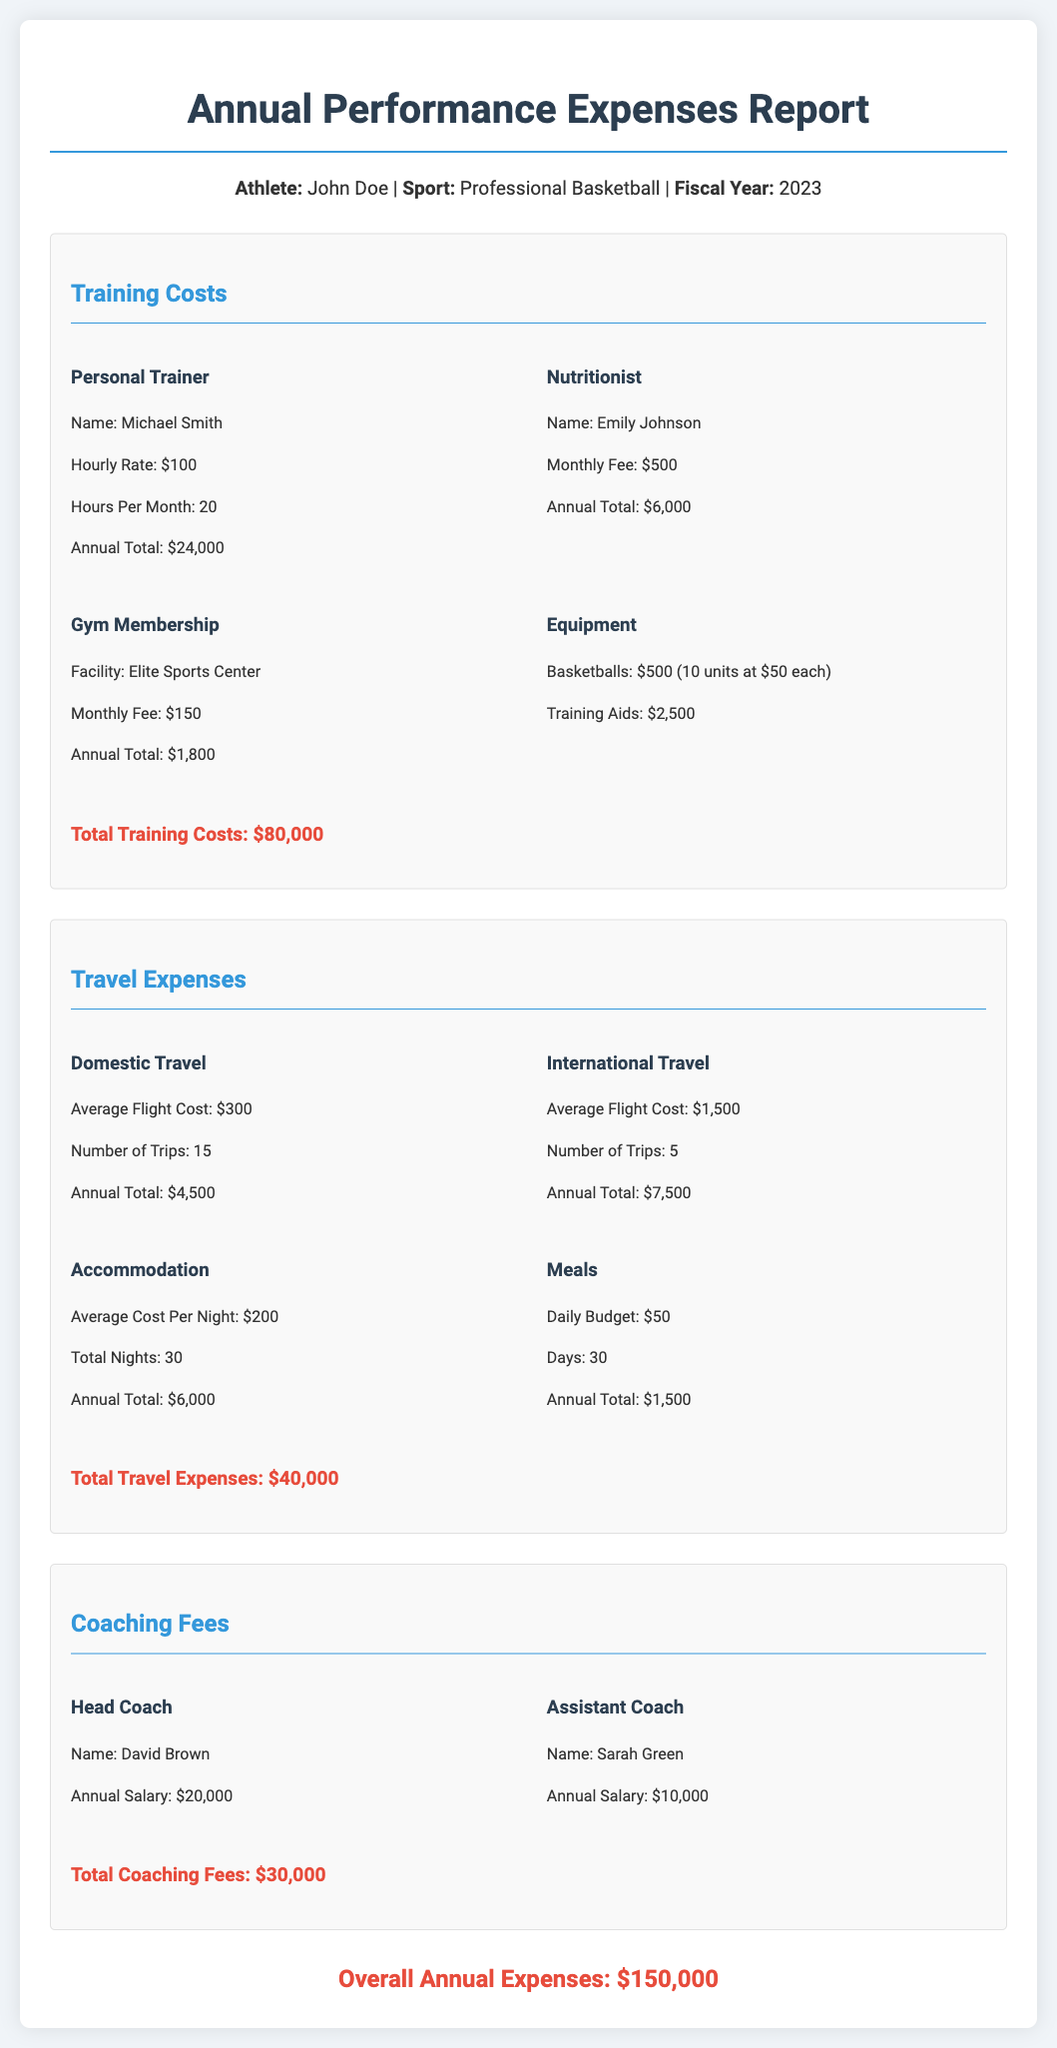What is the total training costs? The total training costs are provided at the end of the training section, totaling all expenses related to training, which is $80,000.
Answer: $80,000 Who is the personal trainer? The document lists the personal trainer's name in the training costs section, which is Michael Smith.
Answer: Michael Smith How many trips were made for domestic travel? The document specifies the number of domestic trips in the travel expenses section, which is 15.
Answer: 15 What is the annual salary of the head coach? The annual salary for the head coach is mentioned in the coaching fees section, which is $20,000.
Answer: $20,000 What is the average cost of an international flight? The average cost for international flights is provided in the travel expenses section as $1,500.
Answer: $1,500 What is the total amount spent on meals during travel? The total spent on meals is indicated in the travel expenses section, which sums to $1,500.
Answer: $1,500 What is the overall annual expenses amount? The overall annual expenses are provided at the end of the document, totaling all expenses, which is $150,000.
Answer: $150,000 How much was spent on equipment? The document specifies spending on equipment under training costs, amounting to $3,000.
Answer: $3,000 What is the monthly fee for the nutritionist? The nutritionist's monthly fee is included in the training costs, which is $500.
Answer: $500 